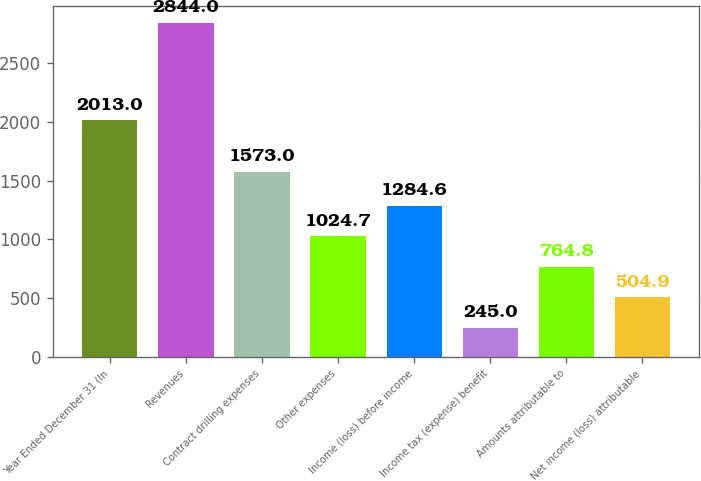<chart> <loc_0><loc_0><loc_500><loc_500><bar_chart><fcel>Year Ended December 31 (In<fcel>Revenues<fcel>Contract drilling expenses<fcel>Other expenses<fcel>Income (loss) before income<fcel>Income tax (expense) benefit<fcel>Amounts attributable to<fcel>Net income (loss) attributable<nl><fcel>2013<fcel>2844<fcel>1573<fcel>1024.7<fcel>1284.6<fcel>245<fcel>764.8<fcel>504.9<nl></chart> 